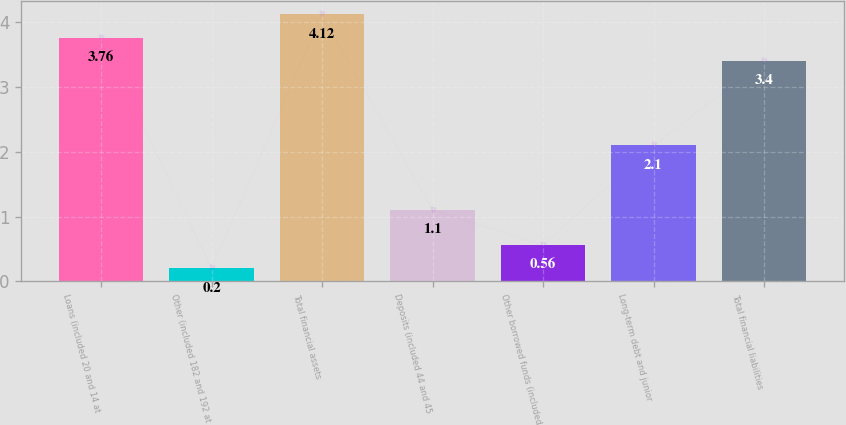<chart> <loc_0><loc_0><loc_500><loc_500><bar_chart><fcel>Loans (included 20 and 14 at<fcel>Other (included 182 and 192 at<fcel>Total financial assets<fcel>Deposits (included 44 and 45<fcel>Other borrowed funds (included<fcel>Long-term debt and junior<fcel>Total financial liabilities<nl><fcel>3.76<fcel>0.2<fcel>4.12<fcel>1.1<fcel>0.56<fcel>2.1<fcel>3.4<nl></chart> 